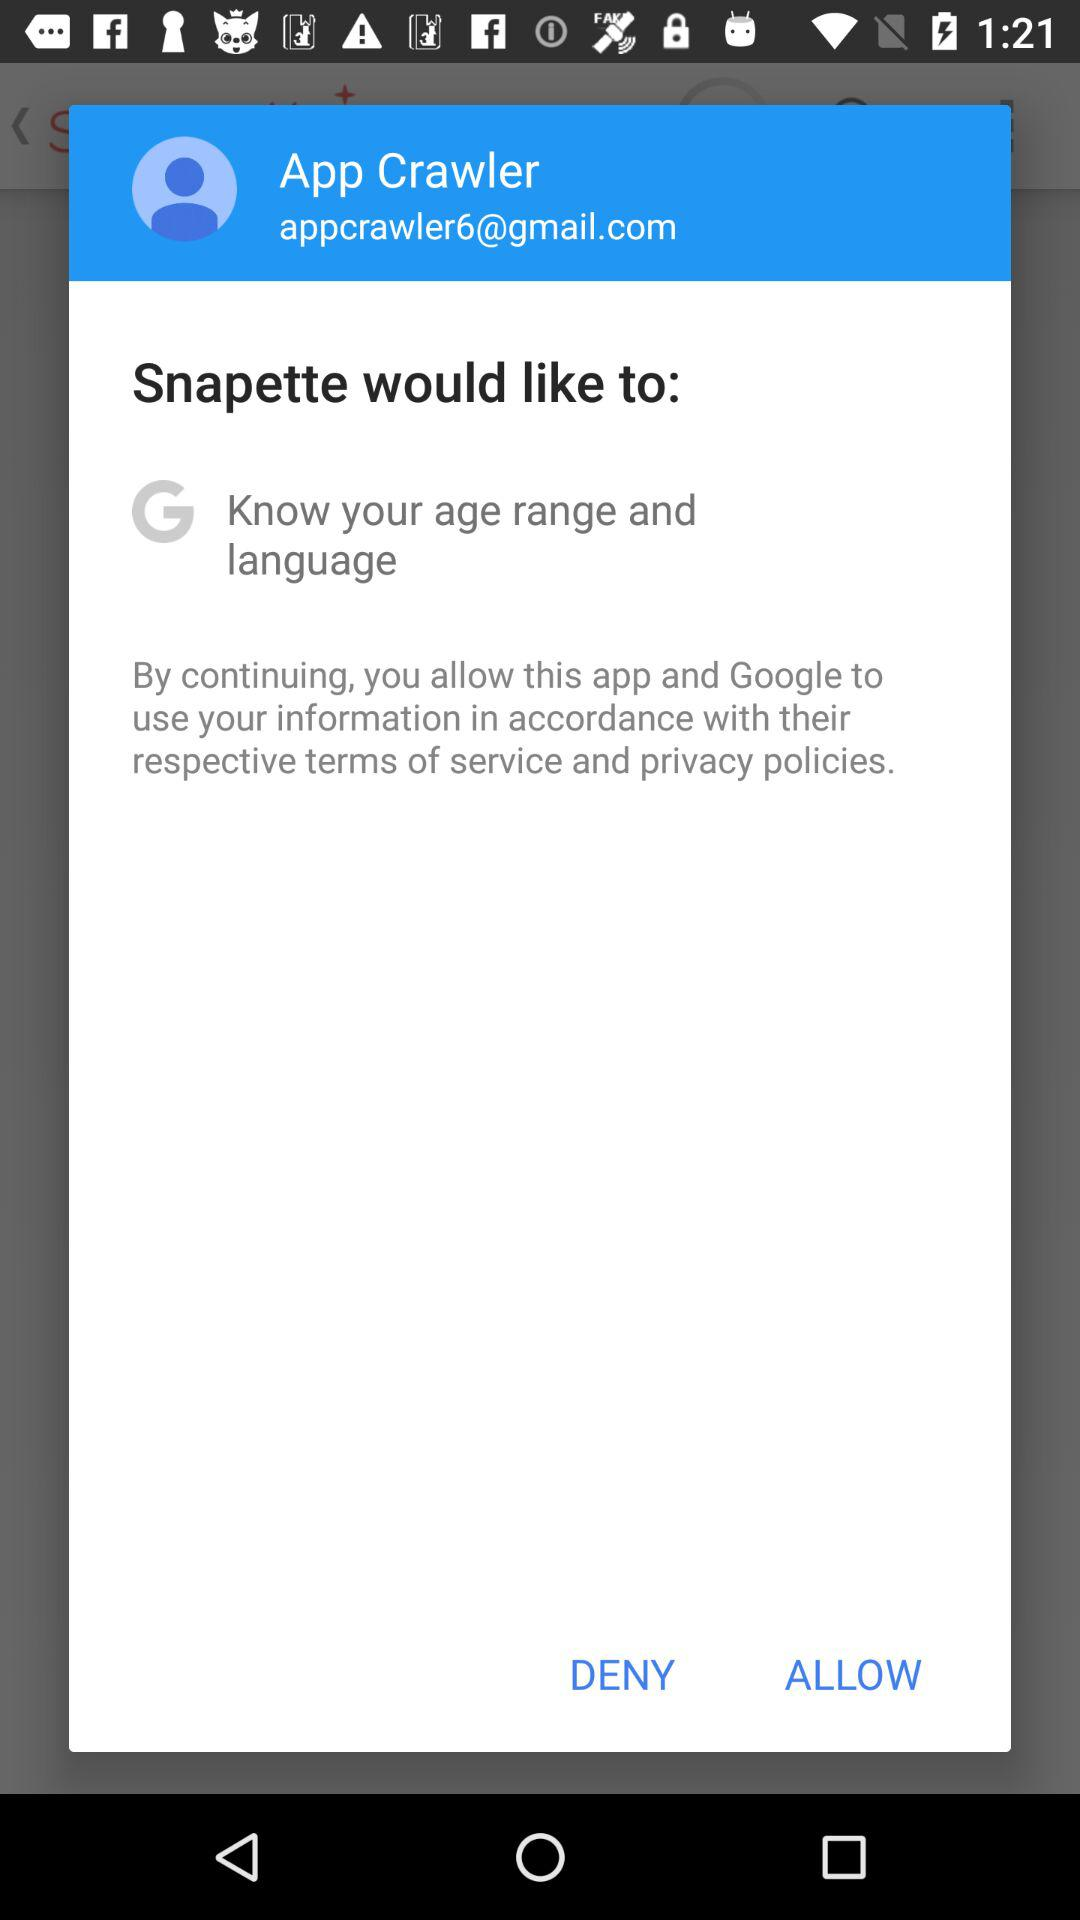What is the email address? The email address is appcrawler6@gmail.com. 